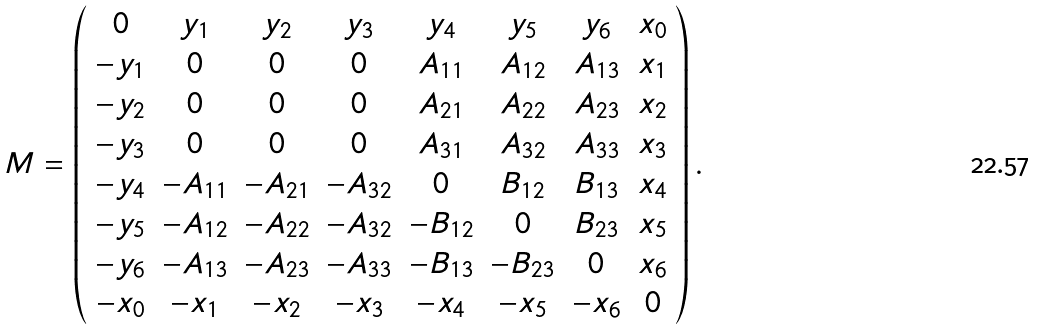Convert formula to latex. <formula><loc_0><loc_0><loc_500><loc_500>M = \left ( \begin{array} { c c c c c c c c } 0 & y _ { 1 } & y _ { 2 } & y _ { 3 } & y _ { 4 } & y _ { 5 } & y _ { 6 } & x _ { 0 } \\ - y _ { 1 } & 0 & 0 & 0 & A _ { 1 1 } & A _ { 1 2 } & A _ { 1 3 } & x _ { 1 } \\ - y _ { 2 } & 0 & 0 & 0 & A _ { 2 1 } & A _ { 2 2 } & A _ { 2 3 } & x _ { 2 } \\ - y _ { 3 } & 0 & 0 & 0 & A _ { 3 1 } & A _ { 3 2 } & A _ { 3 3 } & x _ { 3 } \\ - y _ { 4 } & - A _ { 1 1 } & - A _ { 2 1 } & - A _ { 3 2 } & 0 & B _ { 1 2 } & B _ { 1 3 } & x _ { 4 } \\ - y _ { 5 } & - A _ { 1 2 } & - A _ { 2 2 } & - A _ { 3 2 } & - B _ { 1 2 } & 0 & B _ { 2 3 } & x _ { 5 } \\ - y _ { 6 } & - A _ { 1 3 } & - A _ { 2 3 } & - A _ { 3 3 } & - B _ { 1 3 } & - B _ { 2 3 } & 0 & x _ { 6 } \\ - x _ { 0 } & - x _ { 1 } & - x _ { 2 } & - x _ { 3 } & - x _ { 4 } & - x _ { 5 } & - x _ { 6 } & 0 \end{array} \right ) .</formula> 